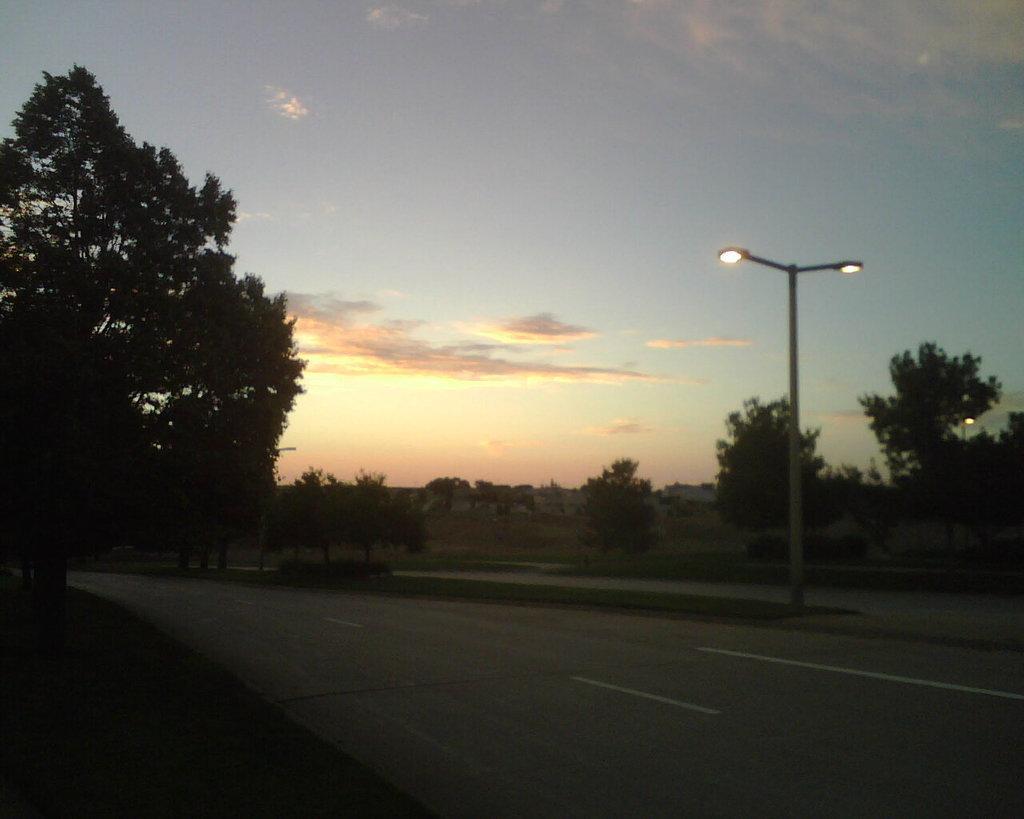Describe this image in one or two sentences. In this picture I can see the farmland, trees, plants and grass. At the bottom I can see the road. On the right I can see some street lights. At the top i can see the sky and clouds. 